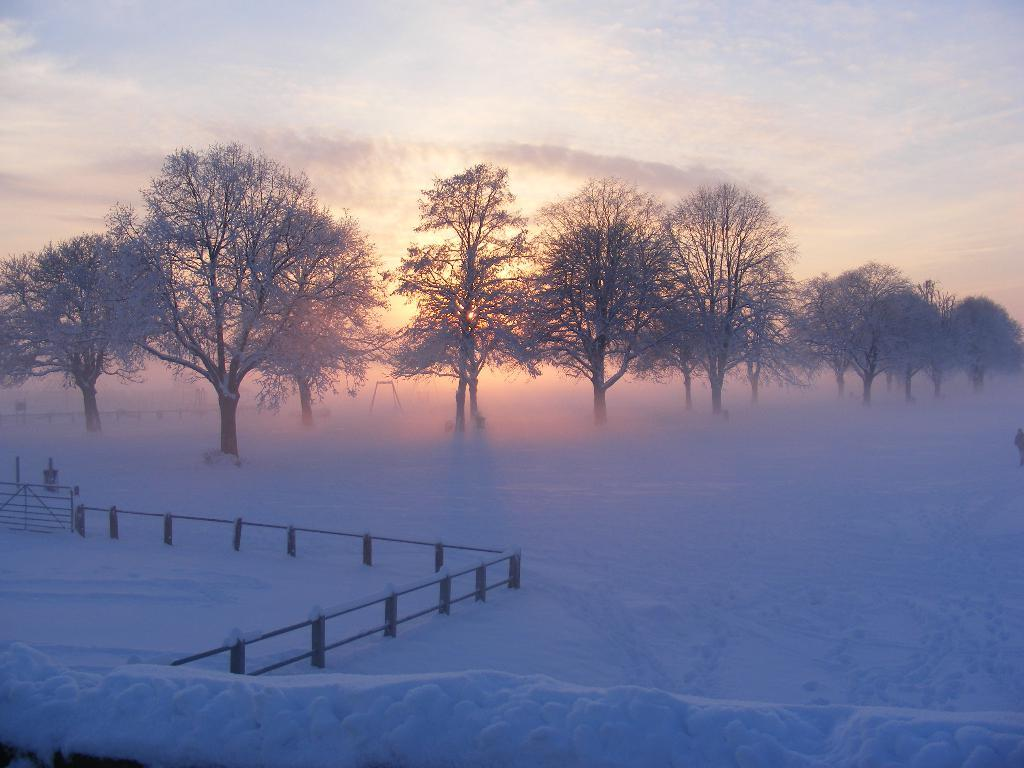What type of weather is depicted in the image? There is snow in the image, indicating cold weather. What can be seen in the image besides the snow? There is fencing and trees visible in the image. What is visible in the background of the image? The sky is visible in the image, and clouds are present in the sky. What type of metal is the governor using to improve their health in the image? There is no governor or metal present in the image, and no mention of improving health. 